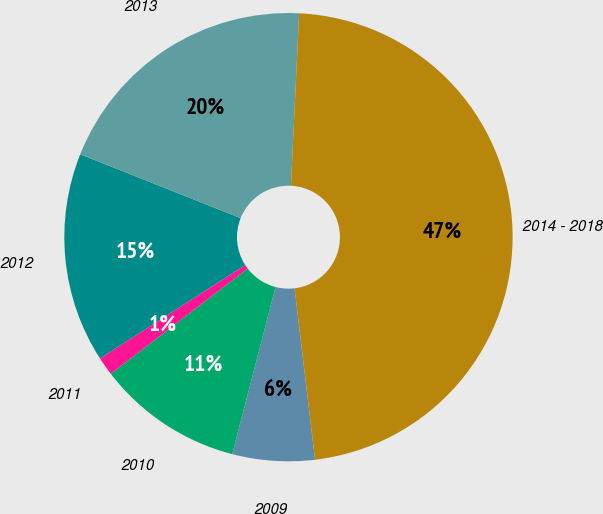<chart> <loc_0><loc_0><loc_500><loc_500><pie_chart><fcel>2009<fcel>2010<fcel>2011<fcel>2012<fcel>2013<fcel>2014 - 2018<nl><fcel>5.93%<fcel>10.53%<fcel>1.33%<fcel>15.13%<fcel>19.73%<fcel>47.35%<nl></chart> 